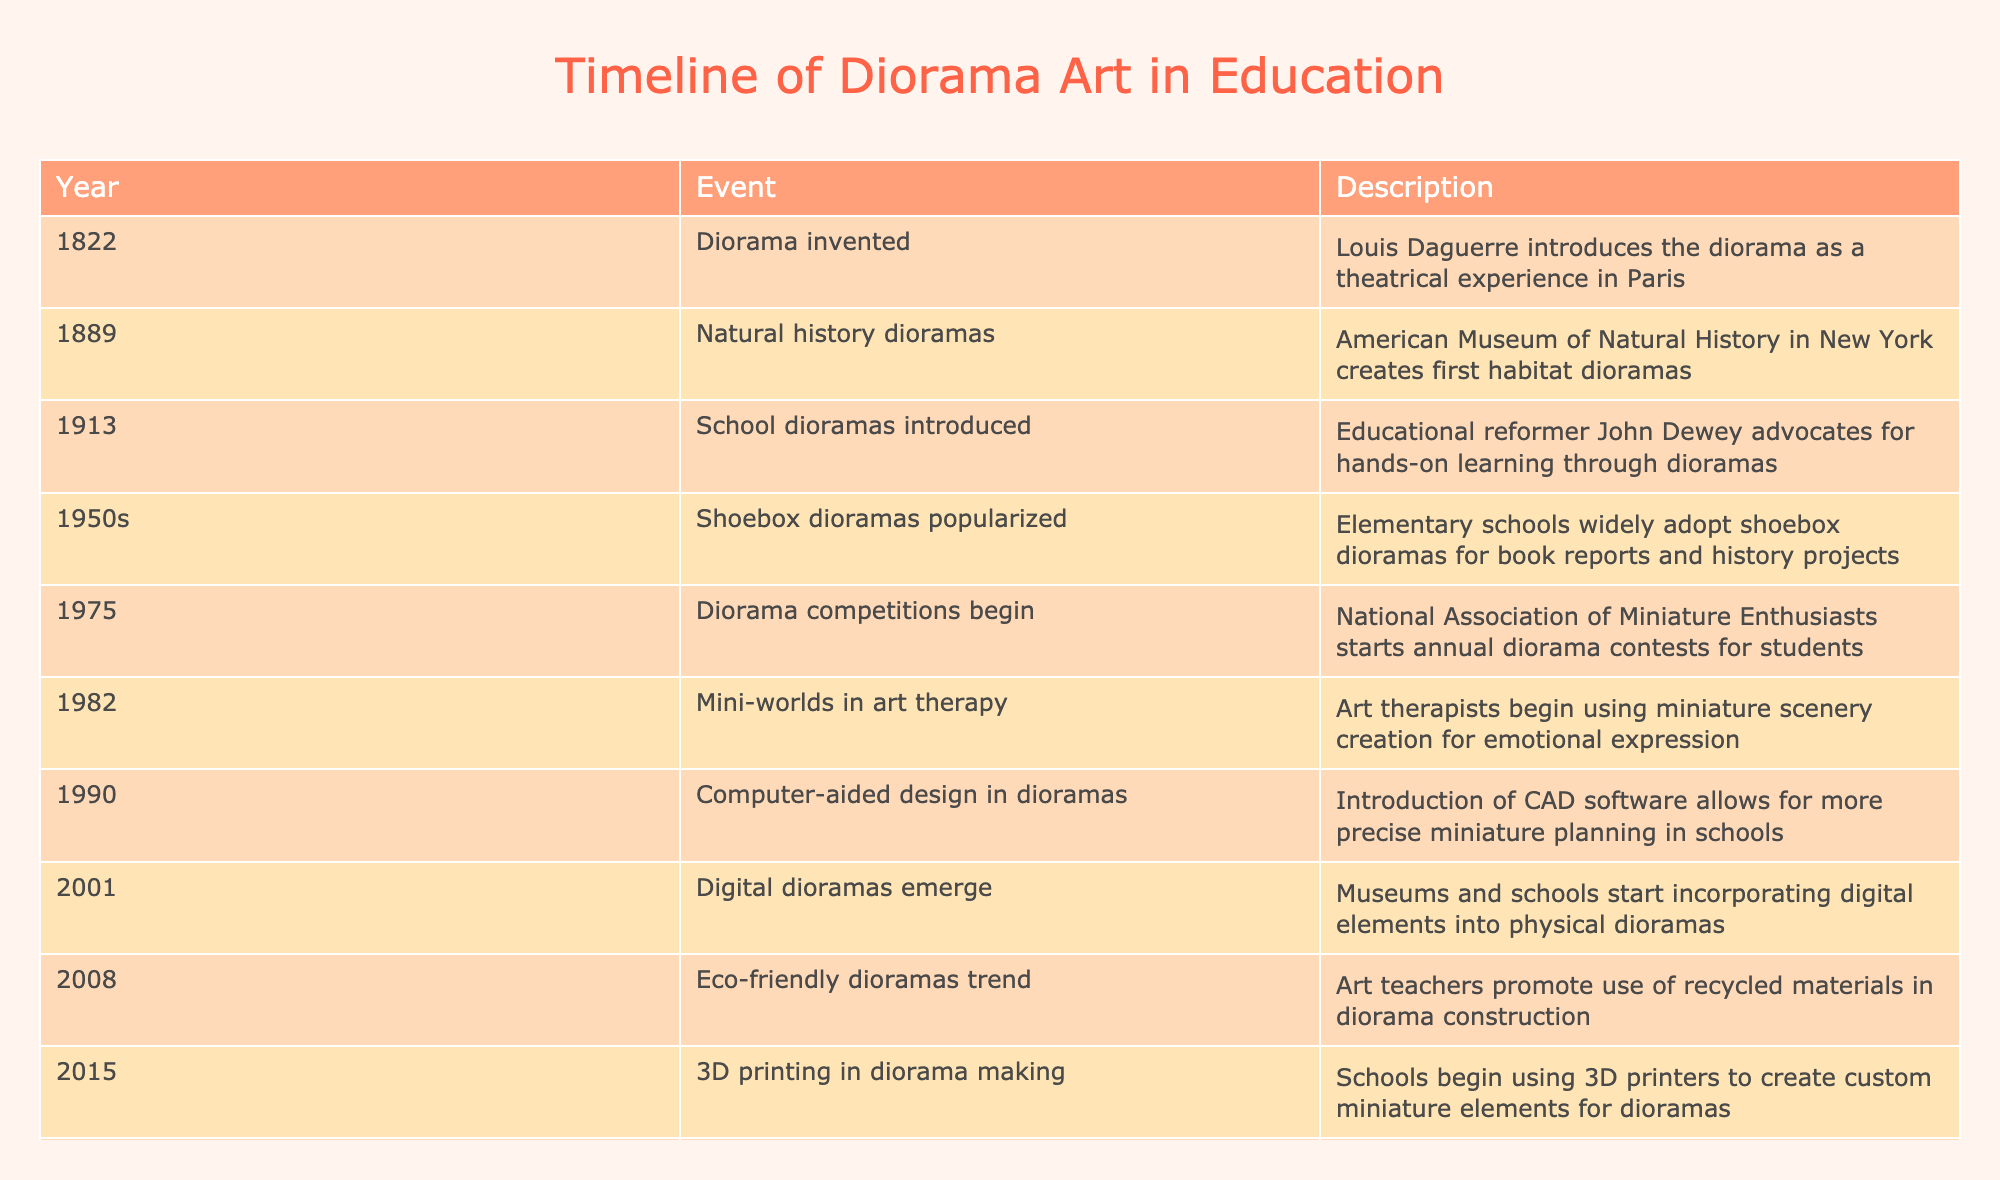What year was the diorama invented? The table indicates that the diorama was invented in the year 1822 by Louis Daguerre.
Answer: 1822 Which event in the table marks the introduction of school dioramas? According to the table, the introduction of school dioramas occurred in 1913 when educational reformer John Dewey advocated for hands-on learning through dioramas.
Answer: 1913 What trend began in 2008 according to the timeline? The table specifies that in 2008, the trend of eco-friendly dioramas began, with art teachers promoting the use of recycled materials in diorama construction.
Answer: Eco-friendly dioramas trend How many years passed between the invention of the diorama and the popularization of shoebox dioramas? The diorama was invented in 1822, and shoebox dioramas became popularized in the 1950s. Calculating between these years gives us approximately 30 years, as the 1950s can be taken as 1950 for calculation.
Answer: 30 years Was 3D printing first introduced in diorama making before or after the trend of eco-friendly dioramas? The table shows that the trend of eco-friendly dioramas started in 2008, while 3D printing in diorama making began in 2015, indicating that 3D printing was introduced after the eco-friendly trend.
Answer: After In what ways did technology impact dioramas based on the table? According to the table, technology impacted dioramas in several ways: CAD software was introduced in 1990 for precise planning, digital dioramas emerged in 2001 incorporating digital elements, and 3D printing started in 2015 to create custom miniature elements.
Answer: Multiple ways through CAD, digital elements, and 3D printing Which event between 2001 and 2020 involved a significant change due to the COVID-19 pandemic? The table reveals that in 2020, the COVID-19 pandemic led to virtual diorama exhibitions, which was a significant change from previous practices of showcasing dioramas in person.
Answer: Virtual diorama exhibitions What percentage of the events listed pertain to technological advancements in dioramas? To calculate the percentage, count the events related to technology: 1990 (CAD), 2001 (Digital), and 2015 (3D printing), which gives us 3 events out of a total of 10. Thus, (3/10) × 100 = 30%.
Answer: 30% 